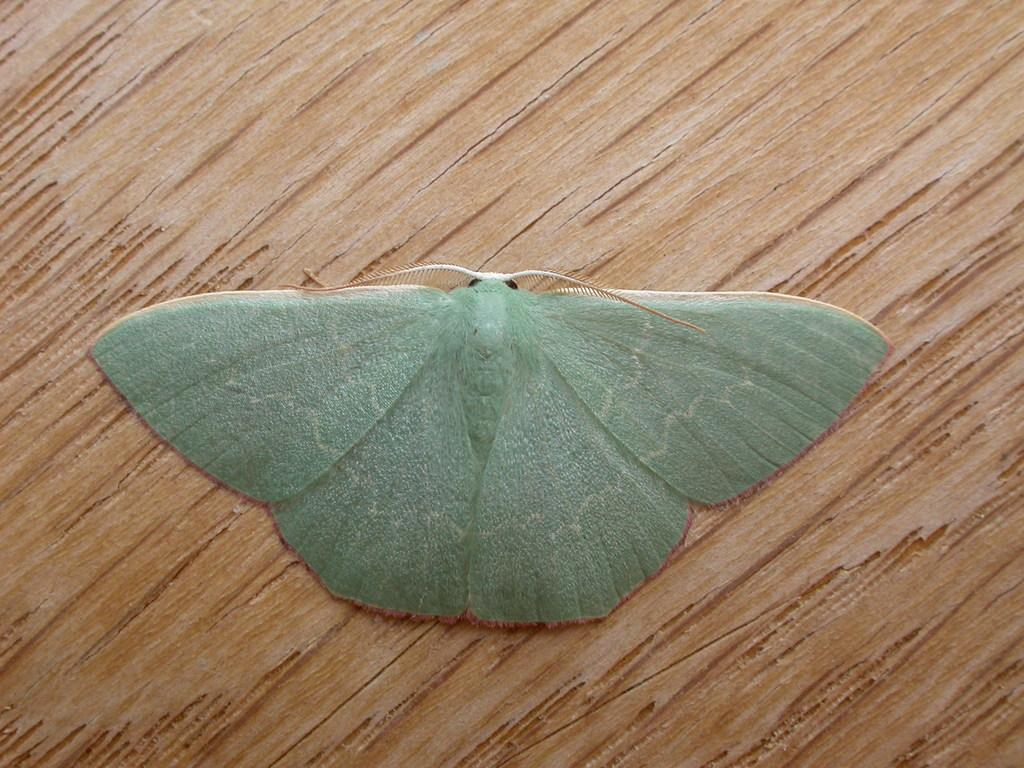What is the main subject of the image? There is an insect in the image. Where is the insect located in the image? The insect is in the center of the image. What surface is the insect on? The insect is on a table. What time of day is it in the image, and is the insect laughing? The time of day is not mentioned in the image, and insects do not have the ability to laugh. 